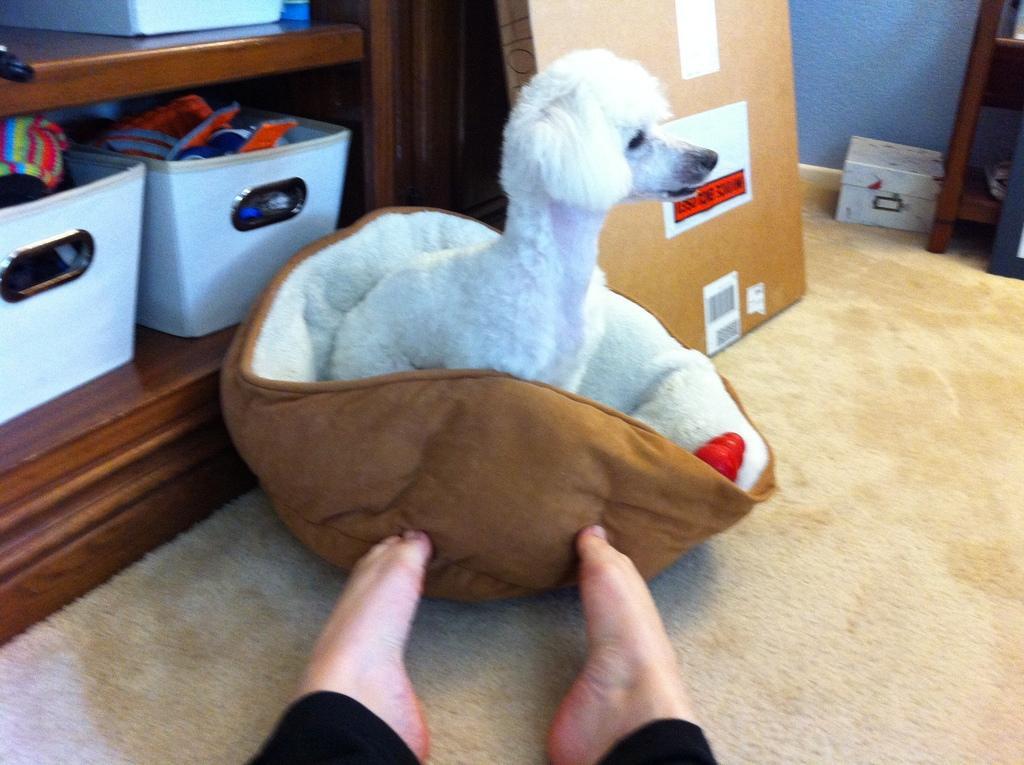Describe this image in one or two sentences. In this picture it looks like a small puppy in a towel kept on the carpet floor. In the background, we see baskets with things inside them. 